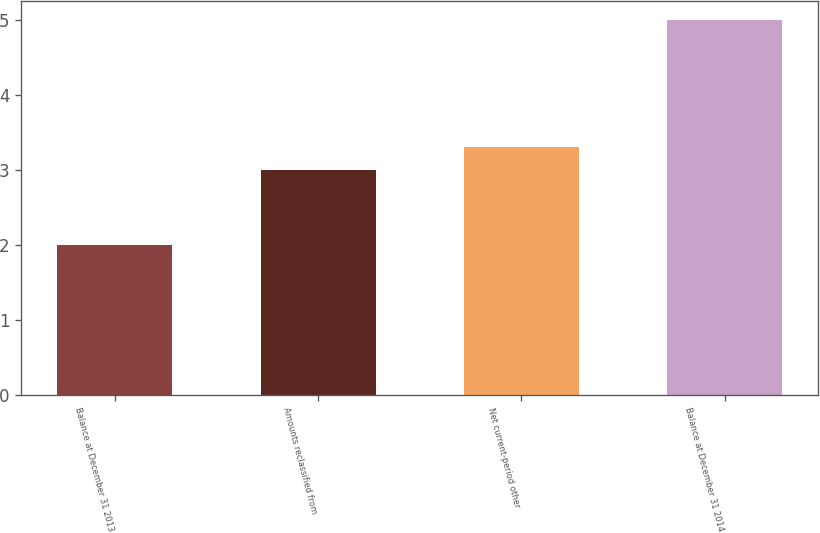<chart> <loc_0><loc_0><loc_500><loc_500><bar_chart><fcel>Balance at December 31 2013<fcel>Amounts reclassified from<fcel>Net current-period other<fcel>Balance at December 31 2014<nl><fcel>2<fcel>3<fcel>3.3<fcel>5<nl></chart> 